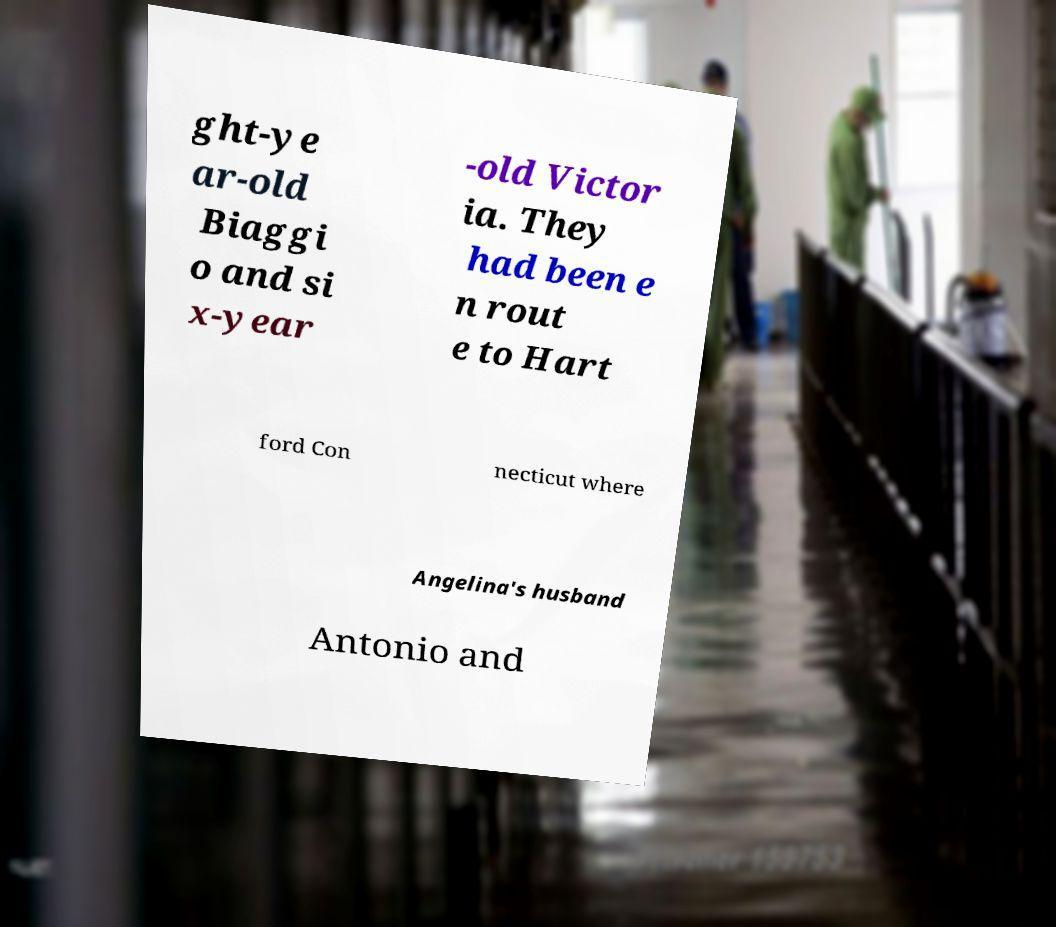Please identify and transcribe the text found in this image. ght-ye ar-old Biaggi o and si x-year -old Victor ia. They had been e n rout e to Hart ford Con necticut where Angelina's husband Antonio and 